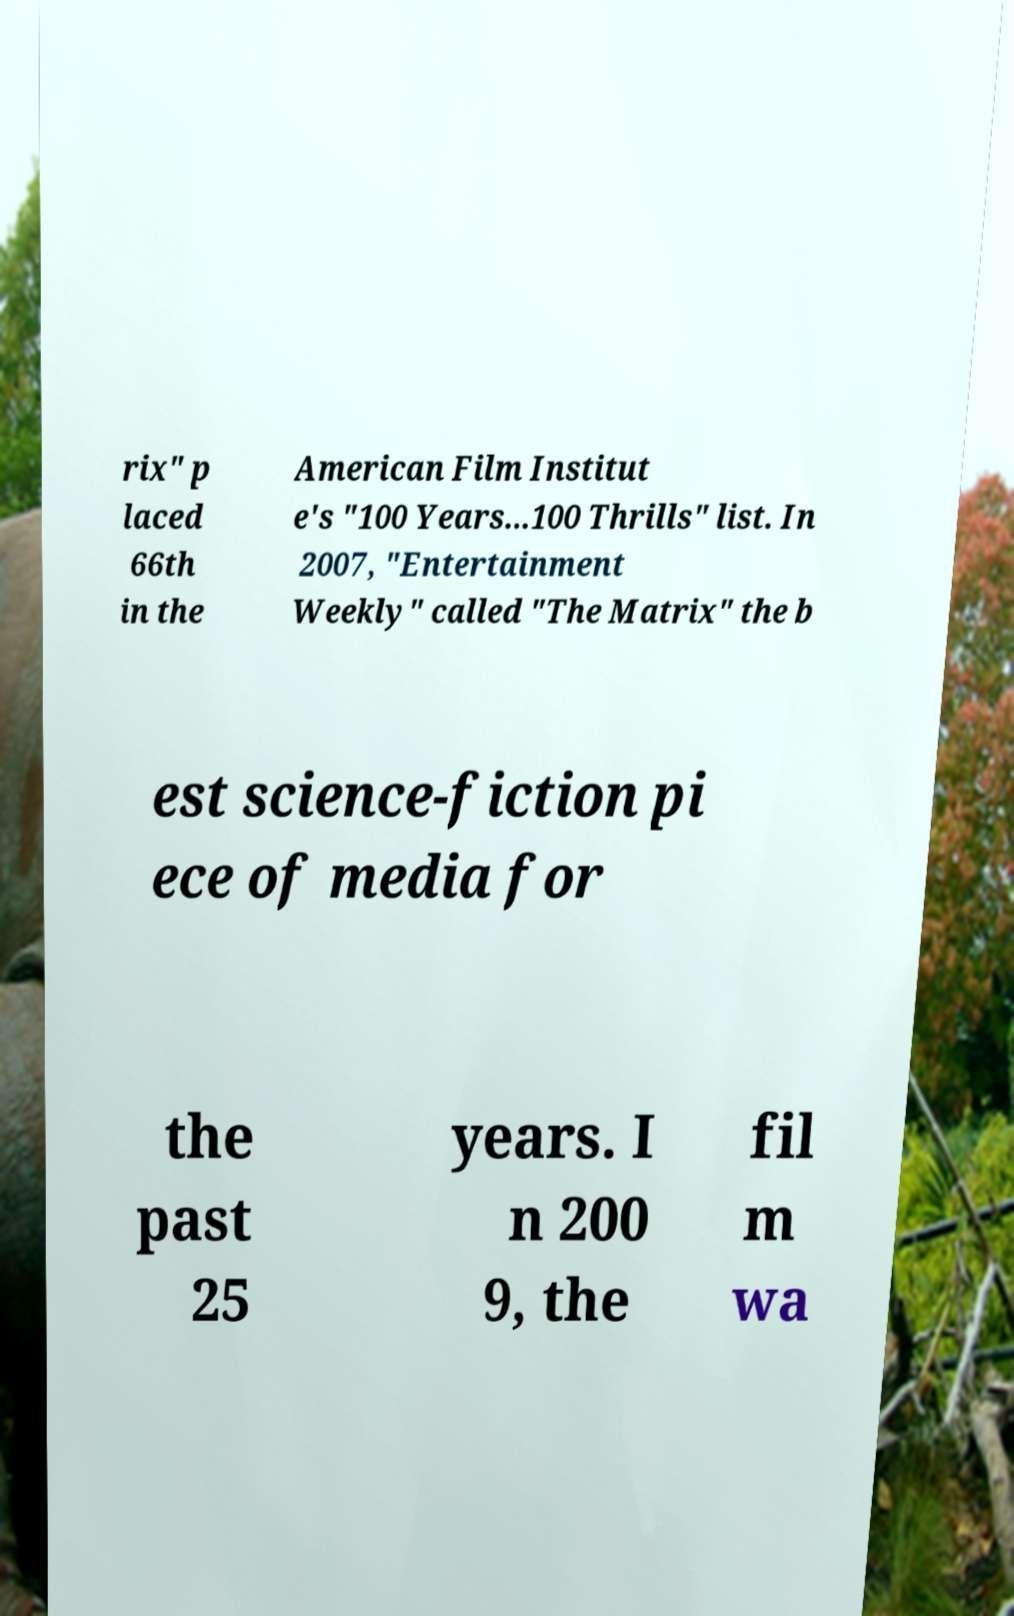What messages or text are displayed in this image? I need them in a readable, typed format. rix" p laced 66th in the American Film Institut e's "100 Years...100 Thrills" list. In 2007, "Entertainment Weekly" called "The Matrix" the b est science-fiction pi ece of media for the past 25 years. I n 200 9, the fil m wa 